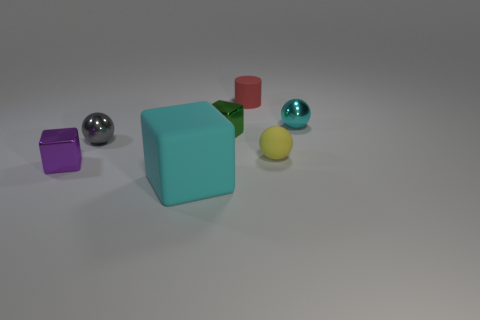Are there any other things that have the same size as the cyan block?
Offer a very short reply. No. Is there anything else that is the same color as the small cylinder?
Offer a terse response. No. Are the small block right of the big thing and the tiny sphere to the left of the red cylinder made of the same material?
Your answer should be compact. Yes. What material is the small thing that is both behind the small purple object and left of the cyan matte cube?
Your answer should be very brief. Metal. Does the green object have the same shape as the cyan thing that is in front of the small yellow object?
Offer a terse response. Yes. There is a yellow ball on the right side of the sphere that is left of the red matte cylinder to the right of the small green cube; what is its material?
Make the answer very short. Rubber. What number of other things are the same size as the yellow sphere?
Make the answer very short. 5. There is a tiny shiny object that is in front of the small shiny sphere to the left of the cyan rubber object; what number of tiny objects are right of it?
Provide a succinct answer. 5. What is the large cube that is in front of the tiny ball that is in front of the tiny gray metal sphere made of?
Provide a short and direct response. Rubber. Are there any brown shiny things that have the same shape as the purple metallic object?
Your answer should be very brief. No. 